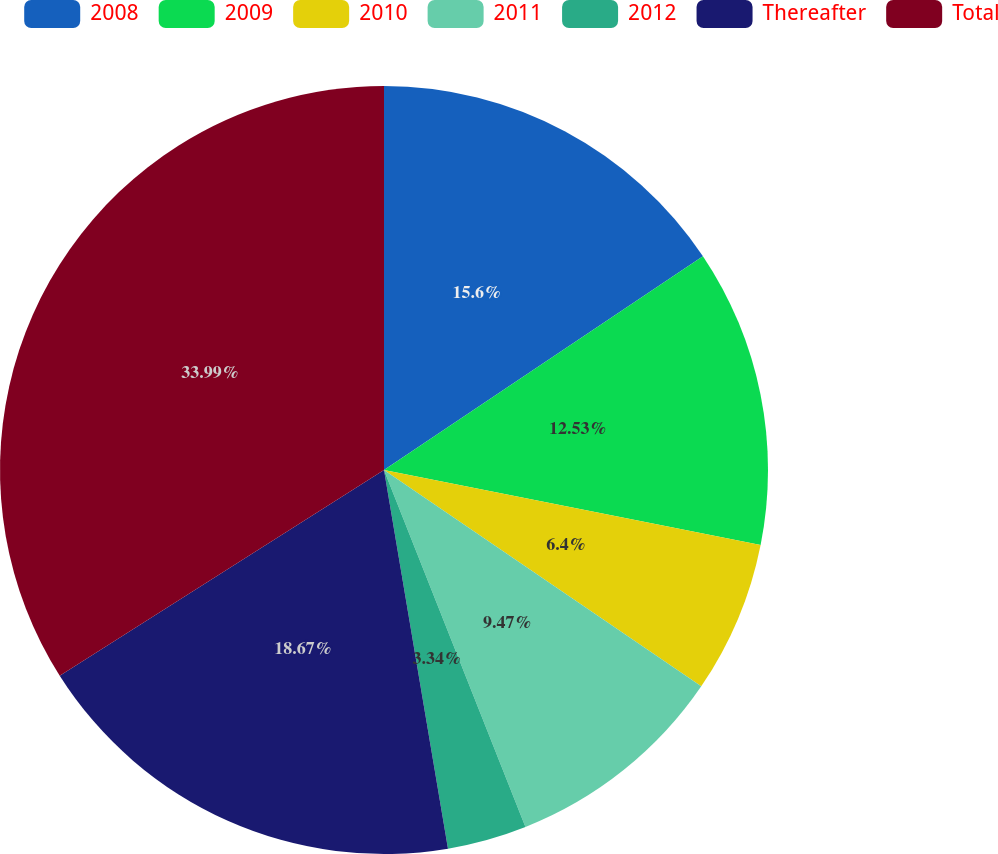<chart> <loc_0><loc_0><loc_500><loc_500><pie_chart><fcel>2008<fcel>2009<fcel>2010<fcel>2011<fcel>2012<fcel>Thereafter<fcel>Total<nl><fcel>15.6%<fcel>12.53%<fcel>6.4%<fcel>9.47%<fcel>3.34%<fcel>18.67%<fcel>34.0%<nl></chart> 